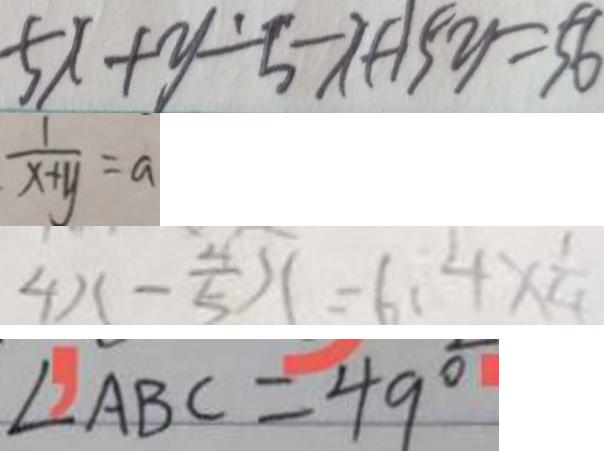Convert formula to latex. <formula><loc_0><loc_0><loc_500><loc_500>5 x + y - 5 - x + 1 5 y = 5 6 
 \frac { 1 } { x + y } = a 
 4 x - \frac { 4 } { 5 } x = 6 . 4 \times \frac { 1 } { 4 } 
 \angle A B C = 4 9 ^ { \circ }</formula> 